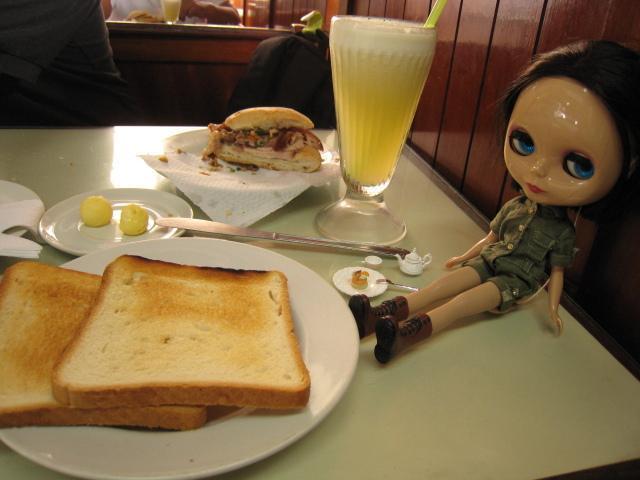How many slices of bread are there?
Give a very brief answer. 2. How many people can you see?
Give a very brief answer. 1. How many dining tables are in the photo?
Give a very brief answer. 2. How many rolls of toilet paper are there?
Give a very brief answer. 0. 